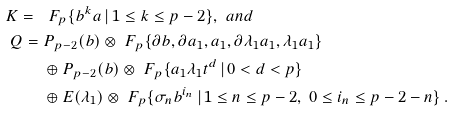<formula> <loc_0><loc_0><loc_500><loc_500>K = \ & \ F _ { p } \{ b ^ { k } a \, | \, 1 \leq k \leq p - 2 \} , \ a n d \\ Q = \ & P _ { p - 2 } ( b ) \otimes \ F _ { p } \{ \partial b , \partial a _ { 1 } , a _ { 1 } , \partial \lambda _ { 1 } a _ { 1 } , \lambda _ { 1 } a _ { 1 } \} \\ & \oplus P _ { p - 2 } ( b ) \otimes \ F _ { p } \{ a _ { 1 } \lambda _ { 1 } t ^ { d } \, | \, 0 < d < p \} \\ & \oplus E ( \lambda _ { 1 } ) \otimes \ F _ { p } \{ \sigma _ { n } b ^ { i _ { n } } \, | \, 1 \leq n \leq p - 2 , \ 0 \leq i _ { n } \leq p - 2 - n \} \, .</formula> 